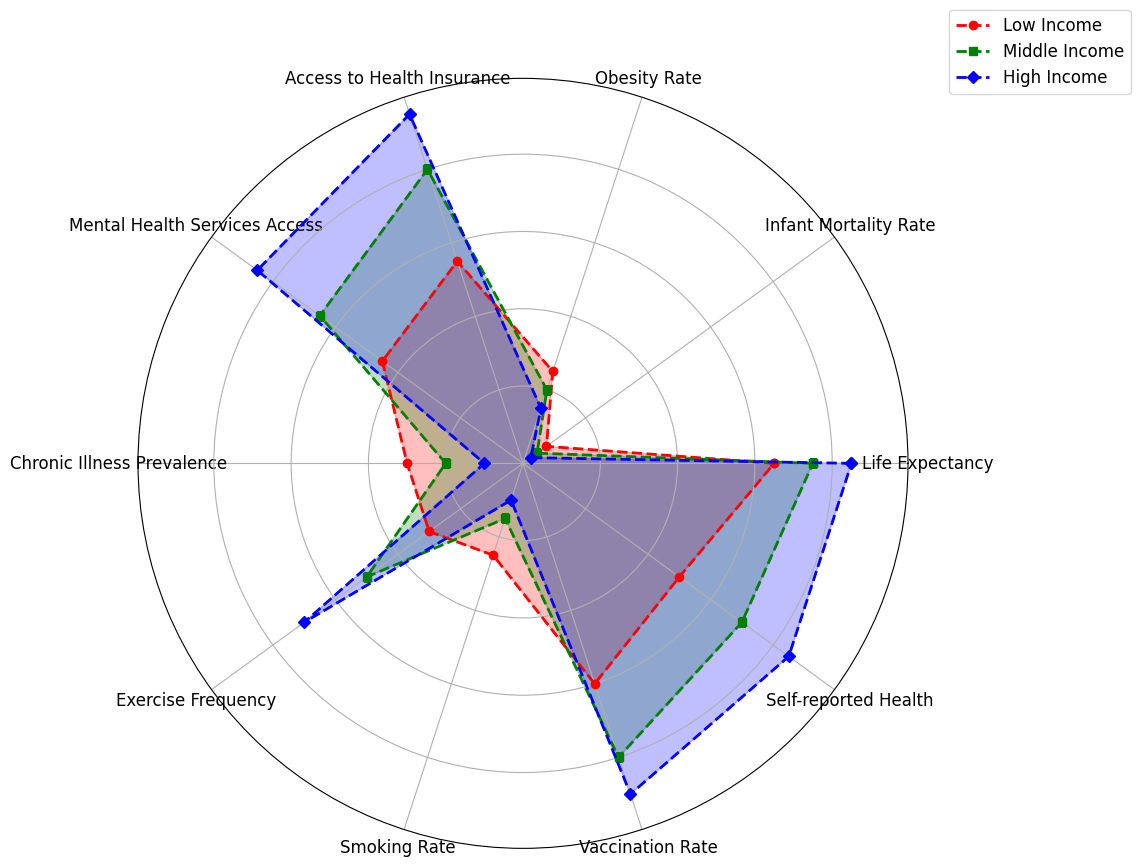Which group has the highest life expectancy? The radar chart shows three lines for life expectancy among different income groups. The blue line (representing high income) extends furthest along the life expectancy axis compared to the red (low income) and green (middle income) lines.
Answer: High Income What is the difference in vaccination rate between the low income and high income groups? Check the endpoints of the lines along the vaccination rate axis for the low (60) and high (90) income groups. Calculate the difference: 90 - 60 = 30.
Answer: 30 Which group has the lowest obesity rate? Observing the obesity rate axis, the blue line (high income) reaches the lowest point compared to red (low income) and green (middle income).
Answer: High Income Compare the access to health insurance between low and middle income groups. Find the points for access to health insurance on the radar chart for low (55) and middle (80) income groups. The middle-income group reaches a higher value on this axis.
Answer: Middle Income What is the total number of metrics where the high income group performs best? High income performs the best if its line extends furthest for a given metric. Observing all axes, high income performs best in 8 metrics (Life Expectancy, Infant Mortality Rate, Access to Health Insurance, Mental Health Services Access, Chronic Illness Prevalence, Exercise Frequency, Vaccination Rate, Self-reported Health).
Answer: 8 How does the smoking rate for the middle income group compare to the low and high income groups? Observing the smoking rate axis, middle income (15) falls between low (25) and high (10) income groups. It is lower than the low income's value and higher than the high income's value.
Answer: In the Middle What is the average exercise frequency across all three income groups? Look at the exercise frequency points for low (30), middle (50), and high (70) income groups. Average them: (30 + 50 + 70) / 3 = 150 / 3 = 50.
Answer: 50 Which group has the highest access to mental health services? Identify the points on the mental health services access axis for all groups. The blue line (high income) extends the furthest.
Answer: High Income By how much does the self-reported health of the middle income group differ from that of the low income group? Observe the self-reported health axis values for middle (70) and low (50) income groups. Subtract the values: 70 - 50 = 20.
Answer: 20 In how many metrics does the low income group perform better than the middle income group? Compare the values for each metric. Low income performs better in only 1 metric (Smoking Rate).
Answer: 1 